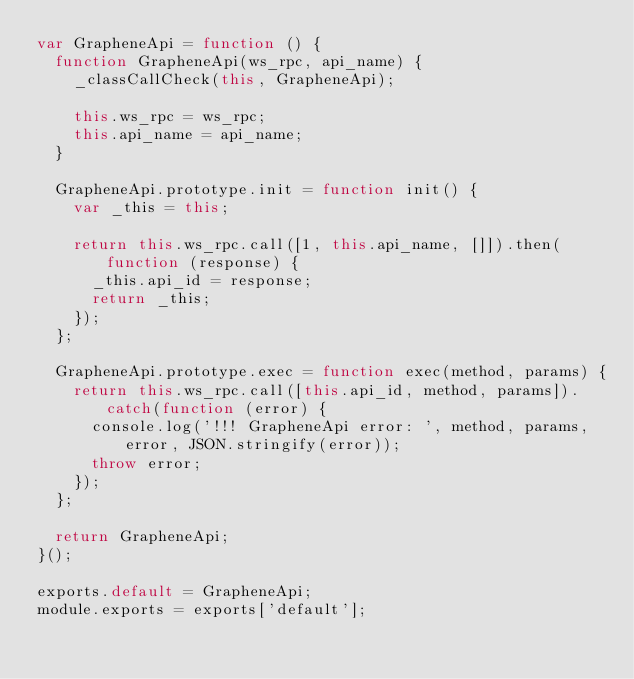Convert code to text. <code><loc_0><loc_0><loc_500><loc_500><_JavaScript_>var GrapheneApi = function () {
  function GrapheneApi(ws_rpc, api_name) {
    _classCallCheck(this, GrapheneApi);

    this.ws_rpc = ws_rpc;
    this.api_name = api_name;
  }

  GrapheneApi.prototype.init = function init() {
    var _this = this;

    return this.ws_rpc.call([1, this.api_name, []]).then(function (response) {
      _this.api_id = response;
      return _this;
    });
  };

  GrapheneApi.prototype.exec = function exec(method, params) {
    return this.ws_rpc.call([this.api_id, method, params]).catch(function (error) {
      console.log('!!! GrapheneApi error: ', method, params, error, JSON.stringify(error));
      throw error;
    });
  };

  return GrapheneApi;
}();

exports.default = GrapheneApi;
module.exports = exports['default'];</code> 